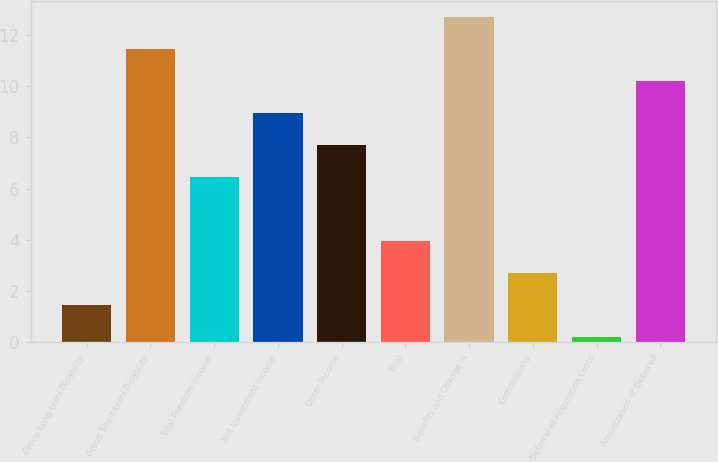Convert chart. <chart><loc_0><loc_0><loc_500><loc_500><bar_chart><fcel>Group Long-term Disability<fcel>Group Short-term Disability<fcel>Total Premium Income<fcel>Net Investment Income<fcel>Other Income<fcel>Total<fcel>Benefits and Change in<fcel>Commissions<fcel>Deferral of Acquisition Costs<fcel>Amortization of Deferred<nl><fcel>1.45<fcel>11.45<fcel>6.45<fcel>8.95<fcel>7.7<fcel>3.95<fcel>12.7<fcel>2.7<fcel>0.2<fcel>10.2<nl></chart> 